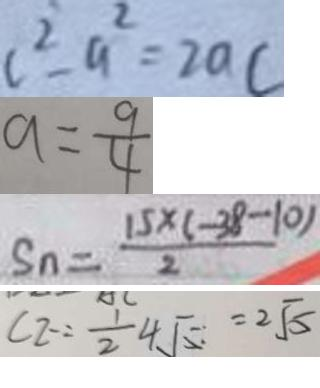Convert formula to latex. <formula><loc_0><loc_0><loc_500><loc_500>c ^ { 2 } - a ^ { 2 } = 2 a c 
 a = \frac { 9 } { 4 } 
 S _ { n } = \frac { 1 5 \times ( - 3 8 - 1 0 ) } { 2 } 
 C 2 = \frac { 1 } { 2 } 4 \sqrt { 5 } = 2 \sqrt { 5 }</formula> 